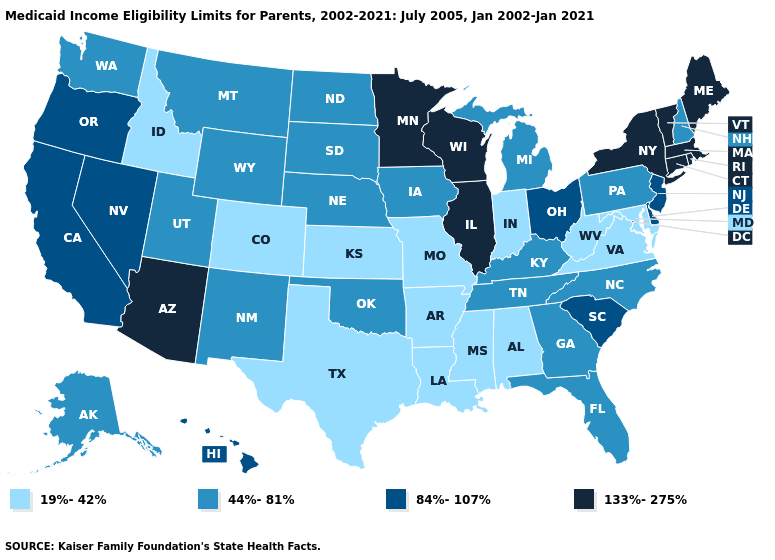Among the states that border Wisconsin , does Illinois have the lowest value?
Concise answer only. No. What is the highest value in the MidWest ?
Concise answer only. 133%-275%. Does New Hampshire have the lowest value in the Northeast?
Answer briefly. Yes. Name the states that have a value in the range 133%-275%?
Quick response, please. Arizona, Connecticut, Illinois, Maine, Massachusetts, Minnesota, New York, Rhode Island, Vermont, Wisconsin. Does Iowa have the lowest value in the USA?
Short answer required. No. What is the lowest value in the USA?
Concise answer only. 19%-42%. Which states have the lowest value in the Northeast?
Give a very brief answer. New Hampshire, Pennsylvania. Which states have the highest value in the USA?
Write a very short answer. Arizona, Connecticut, Illinois, Maine, Massachusetts, Minnesota, New York, Rhode Island, Vermont, Wisconsin. Among the states that border Nebraska , does Missouri have the highest value?
Give a very brief answer. No. Name the states that have a value in the range 133%-275%?
Answer briefly. Arizona, Connecticut, Illinois, Maine, Massachusetts, Minnesota, New York, Rhode Island, Vermont, Wisconsin. Name the states that have a value in the range 133%-275%?
Keep it brief. Arizona, Connecticut, Illinois, Maine, Massachusetts, Minnesota, New York, Rhode Island, Vermont, Wisconsin. What is the value of Minnesota?
Quick response, please. 133%-275%. What is the value of South Carolina?
Give a very brief answer. 84%-107%. Which states have the highest value in the USA?
Quick response, please. Arizona, Connecticut, Illinois, Maine, Massachusetts, Minnesota, New York, Rhode Island, Vermont, Wisconsin. Name the states that have a value in the range 84%-107%?
Concise answer only. California, Delaware, Hawaii, Nevada, New Jersey, Ohio, Oregon, South Carolina. 